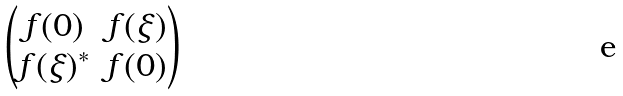<formula> <loc_0><loc_0><loc_500><loc_500>\begin{pmatrix} f ( 0 ) & f ( \xi ) \\ f ( \xi ) ^ { * } & f ( 0 ) \end{pmatrix}</formula> 